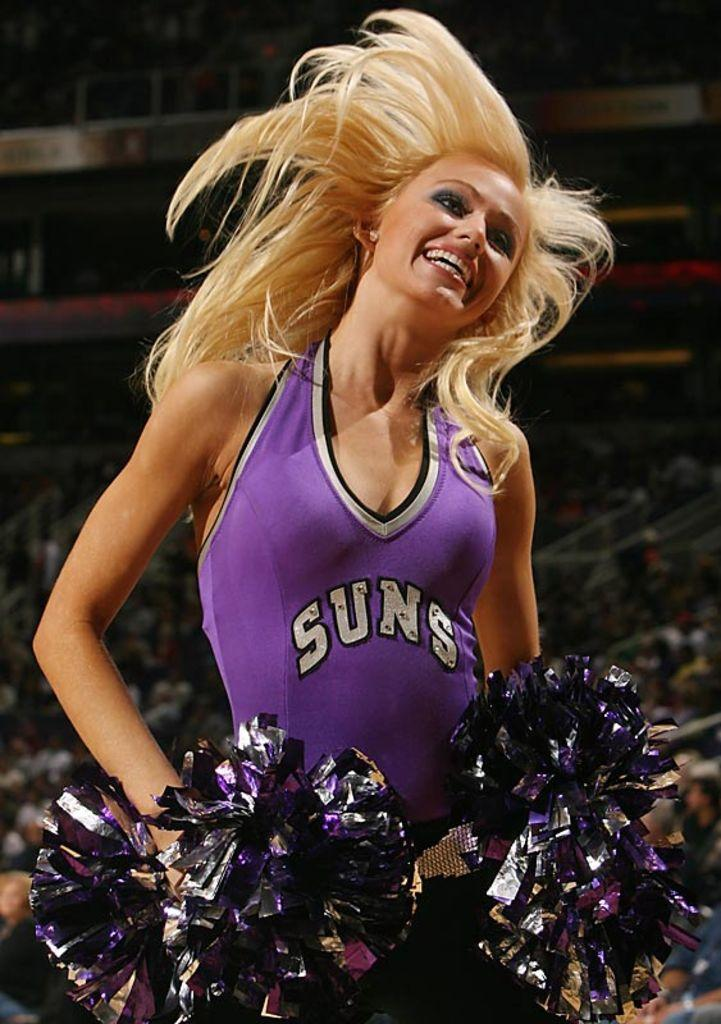<image>
Offer a succinct explanation of the picture presented. Suns basketball cheerleader smiling for a picture and wearing her pom poms 